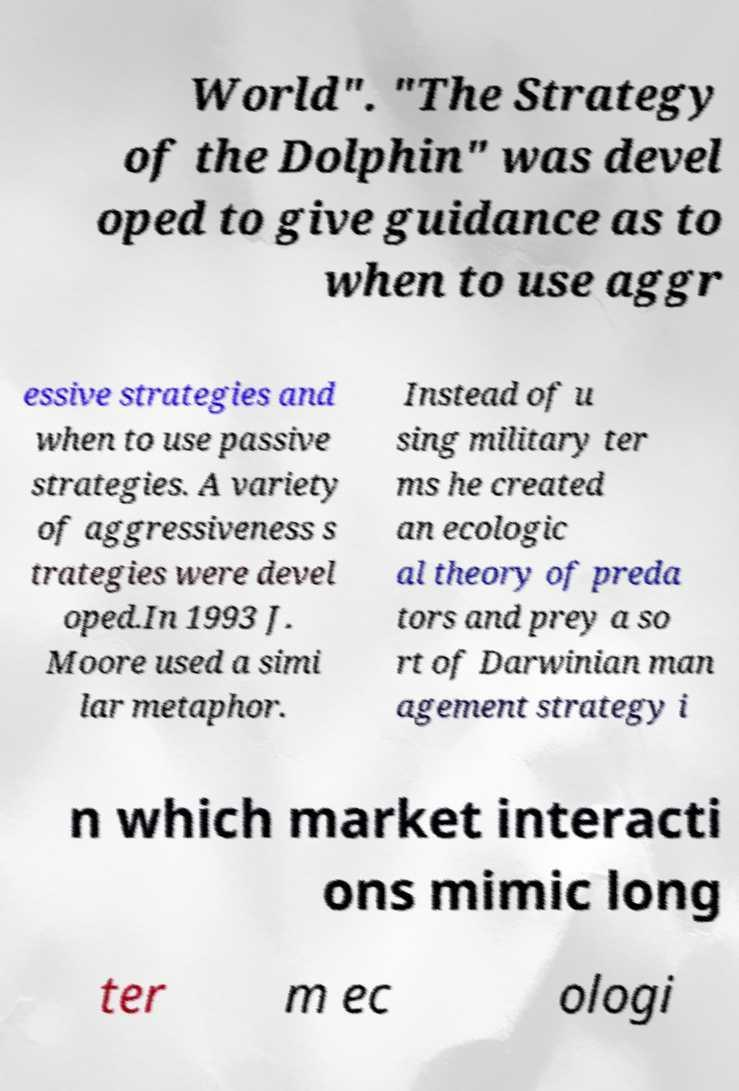Could you assist in decoding the text presented in this image and type it out clearly? World". "The Strategy of the Dolphin" was devel oped to give guidance as to when to use aggr essive strategies and when to use passive strategies. A variety of aggressiveness s trategies were devel oped.In 1993 J. Moore used a simi lar metaphor. Instead of u sing military ter ms he created an ecologic al theory of preda tors and prey a so rt of Darwinian man agement strategy i n which market interacti ons mimic long ter m ec ologi 